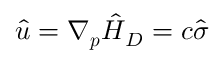<formula> <loc_0><loc_0><loc_500><loc_500>\hat { u } = \nabla _ { p } \hat { H } _ { D } = c \hat { \sigma }</formula> 